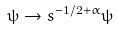Convert formula to latex. <formula><loc_0><loc_0><loc_500><loc_500>\psi \to s ^ { - 1 / 2 + \alpha } \psi</formula> 